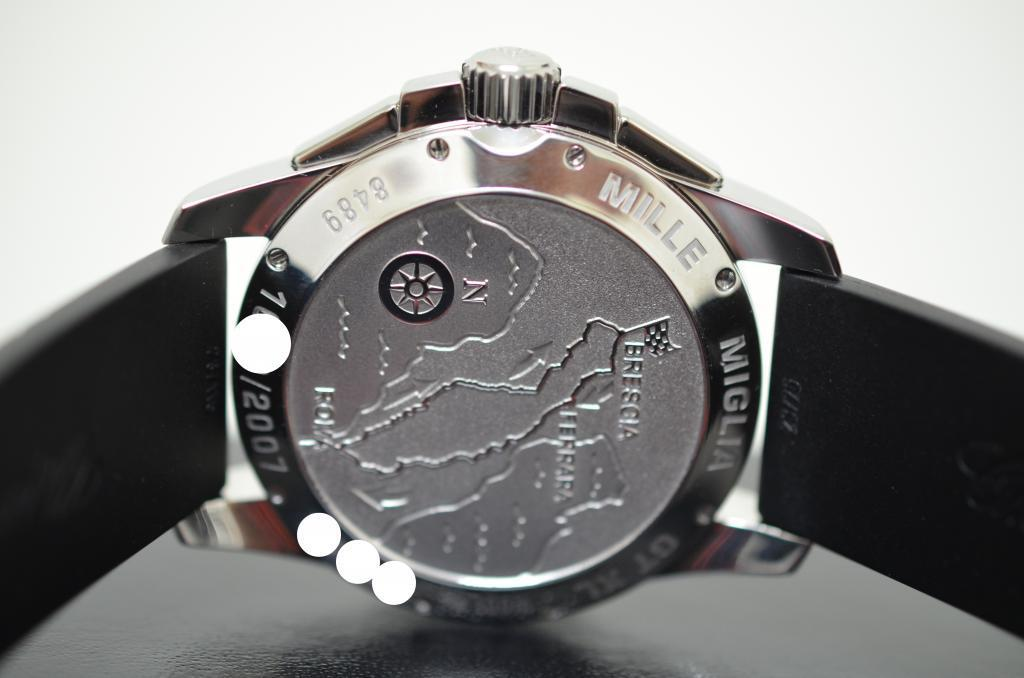Provide a one-sentence caption for the provided image. A watch with the words Mille Miglia on the outer edge. 